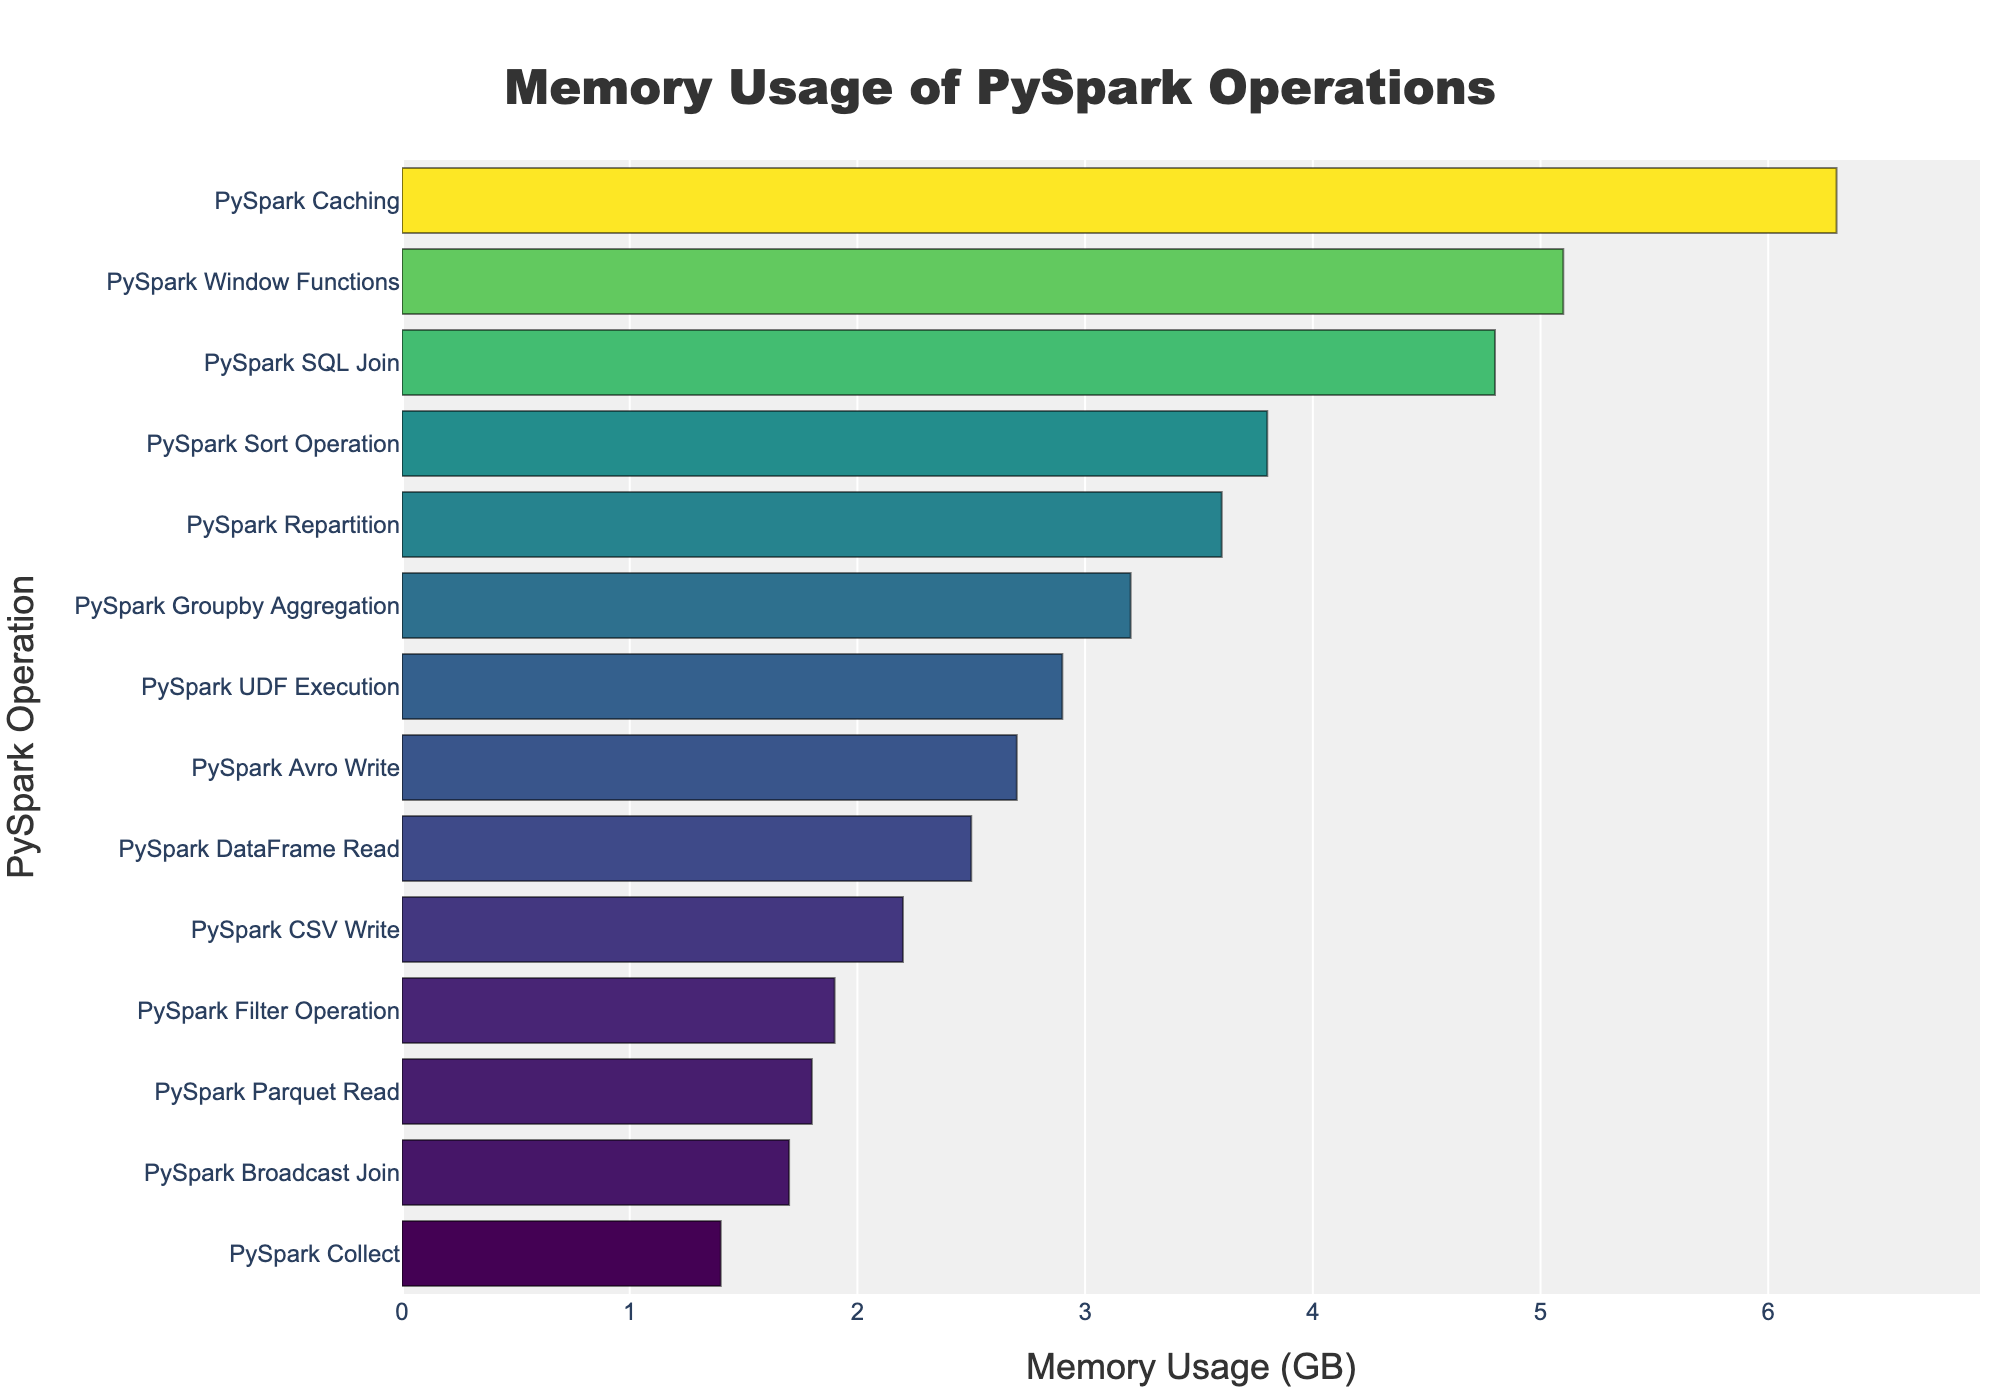Which PySpark operation has the highest memory usage? From the bar chart, the PySpark operation that consumes the most memory is the one with the longest bar. The bar for "PySpark Caching" is the longest, indicating it has the highest memory usage.
Answer: PySpark Caching Which PySpark operation uses more memory, DataFrame Read or CSV Write? To determine which operation uses more memory, compare the lengths of the bars for "PySpark DataFrame Read" and "PySpark CSV Write". The bar for "PySpark DataFrame Read" is longer than the bar for "PySpark CSV Write".
Answer: DataFrame Read What is the total memory usage of PySpark operations that use less than 2 GB? Identify the bars that correspond to memory usages less than 2 GB: "PySpark Collect" (1.4 GB), "PySpark Broadcast Join" (1.7 GB), "PySpark Filter Operation" (1.9 GB), and "PySpark Parquet Read" (1.8 GB). Sum these values: 1.4 + 1.7 + 1.9 + 1.8 = 6.8 GB.
Answer: 6.8 GB Which operation has the second highest memory usage and how much is it? To find the second highest memory usage, identify the second longest bar. The second longest bar corresponds to "PySpark Window Functions", which uses 5.1 GB of memory.
Answer: PySpark Window Functions, 5.1 GB How much more memory does the PySpark UDF Execution use compared to PySpark Broadcast Join? Identify the memory usage for "PySpark UDF Execution" (2.9 GB) and "PySpark Broadcast Join" (1.7 GB). Calculate the difference: 2.9 - 1.7 = 1.2 GB.
Answer: 1.2 GB What is the average memory usage of PySpark operations listed in the chart? Sum the memory usages of all operations and divide by the number of operations. The sum is 2.5 + 4.8 + 3.2 + 5.1 + 2.9 + 1.7 + 3.6 + 6.3 + 1.4 + 1.9 + 3.8 + 2.2 + 1.8 + 2.7 = 44.9 GB. The number of operations is 14. Calculate the average: 44.9 / 14 ≈ 3.21 GB.
Answer: 3.21 GB 